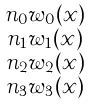Convert formula to latex. <formula><loc_0><loc_0><loc_500><loc_500>\begin{smallmatrix} n _ { 0 } w _ { 0 } ( x ) \\ n _ { 1 } w _ { 1 } ( x ) \\ n _ { 2 } w _ { 2 } ( x ) \\ n _ { 3 } w _ { 3 } ( x ) \end{smallmatrix}</formula> 